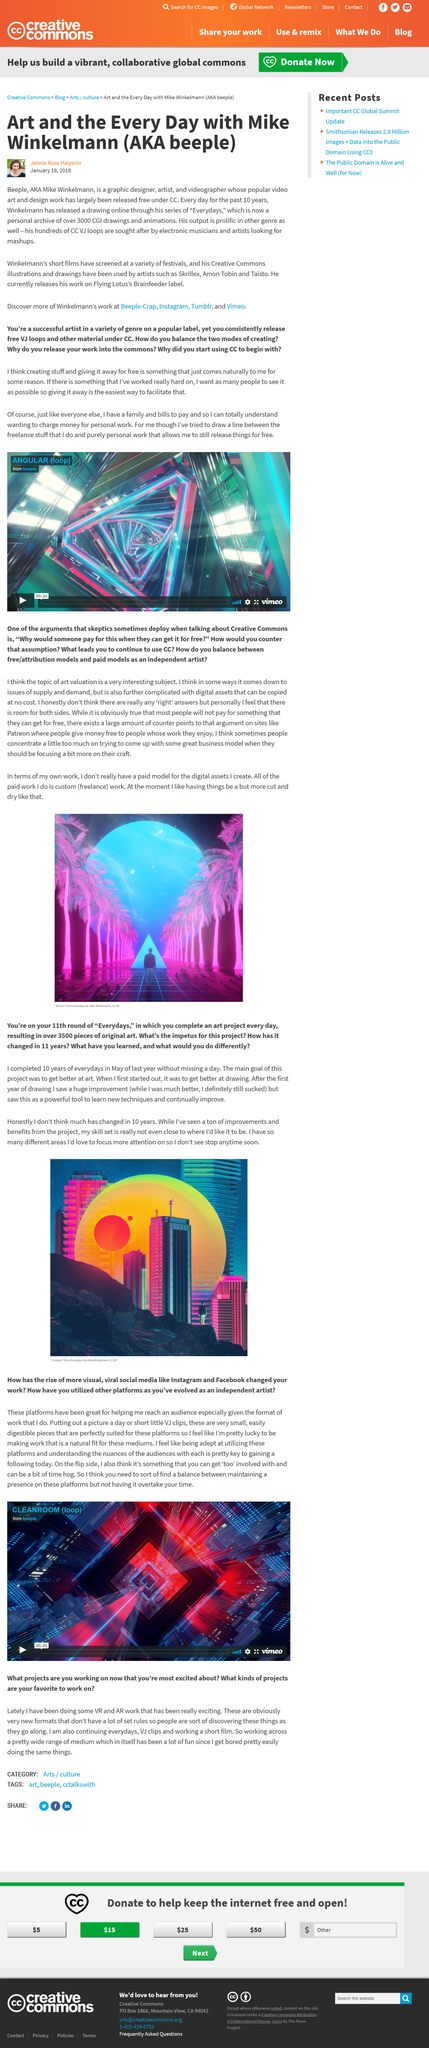Give some essential details in this illustration. The artist known as Beeple, whose real name is Mike Winkelman, is a well-known artist in the digital art community. It has been reported that the artist known as Beeple has released his work on the Flying Lotus-owned Braindfeeder label. Since 2011, Mike Winklemann has been consistently releasing his "Everydays" drawings. 